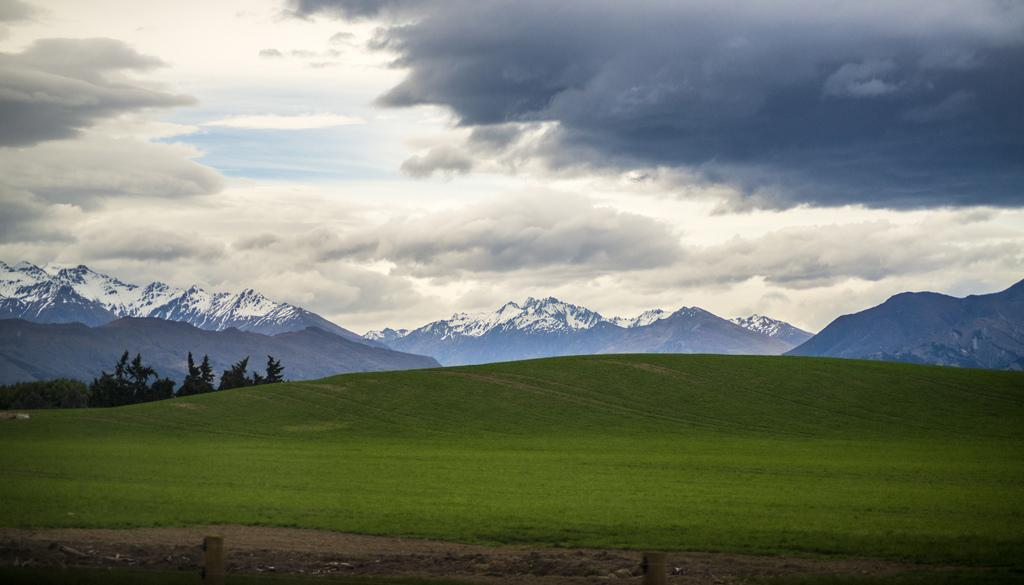What type of natural feature can be seen in the background of the image? There are mountains with snow in the background of the image. What type of vegetation is in the center of the image? There is grass in the center of the image. What is visible at the top of the image? Sky is visible at the top of the image. What can be seen in the sky? Clouds are present in the sky. What other natural elements are in the image? There are trees in the image. What type of guitar is being played by the governor in the image? There is no guitar or governor present in the image. What is the governor's opinion on the lip balm in the image? There is no lip balm or governor present in the image. 